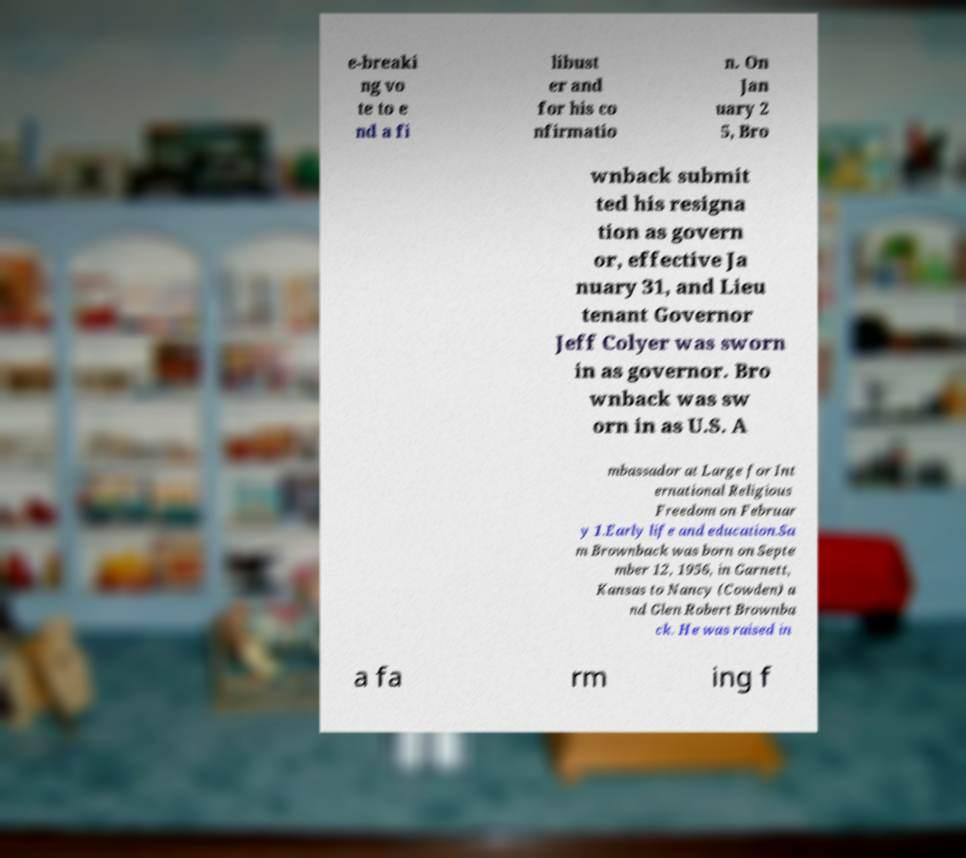What messages or text are displayed in this image? I need them in a readable, typed format. e-breaki ng vo te to e nd a fi libust er and for his co nfirmatio n. On Jan uary 2 5, Bro wnback submit ted his resigna tion as govern or, effective Ja nuary 31, and Lieu tenant Governor Jeff Colyer was sworn in as governor. Bro wnback was sw orn in as U.S. A mbassador at Large for Int ernational Religious Freedom on Februar y 1.Early life and education.Sa m Brownback was born on Septe mber 12, 1956, in Garnett, Kansas to Nancy (Cowden) a nd Glen Robert Brownba ck. He was raised in a fa rm ing f 